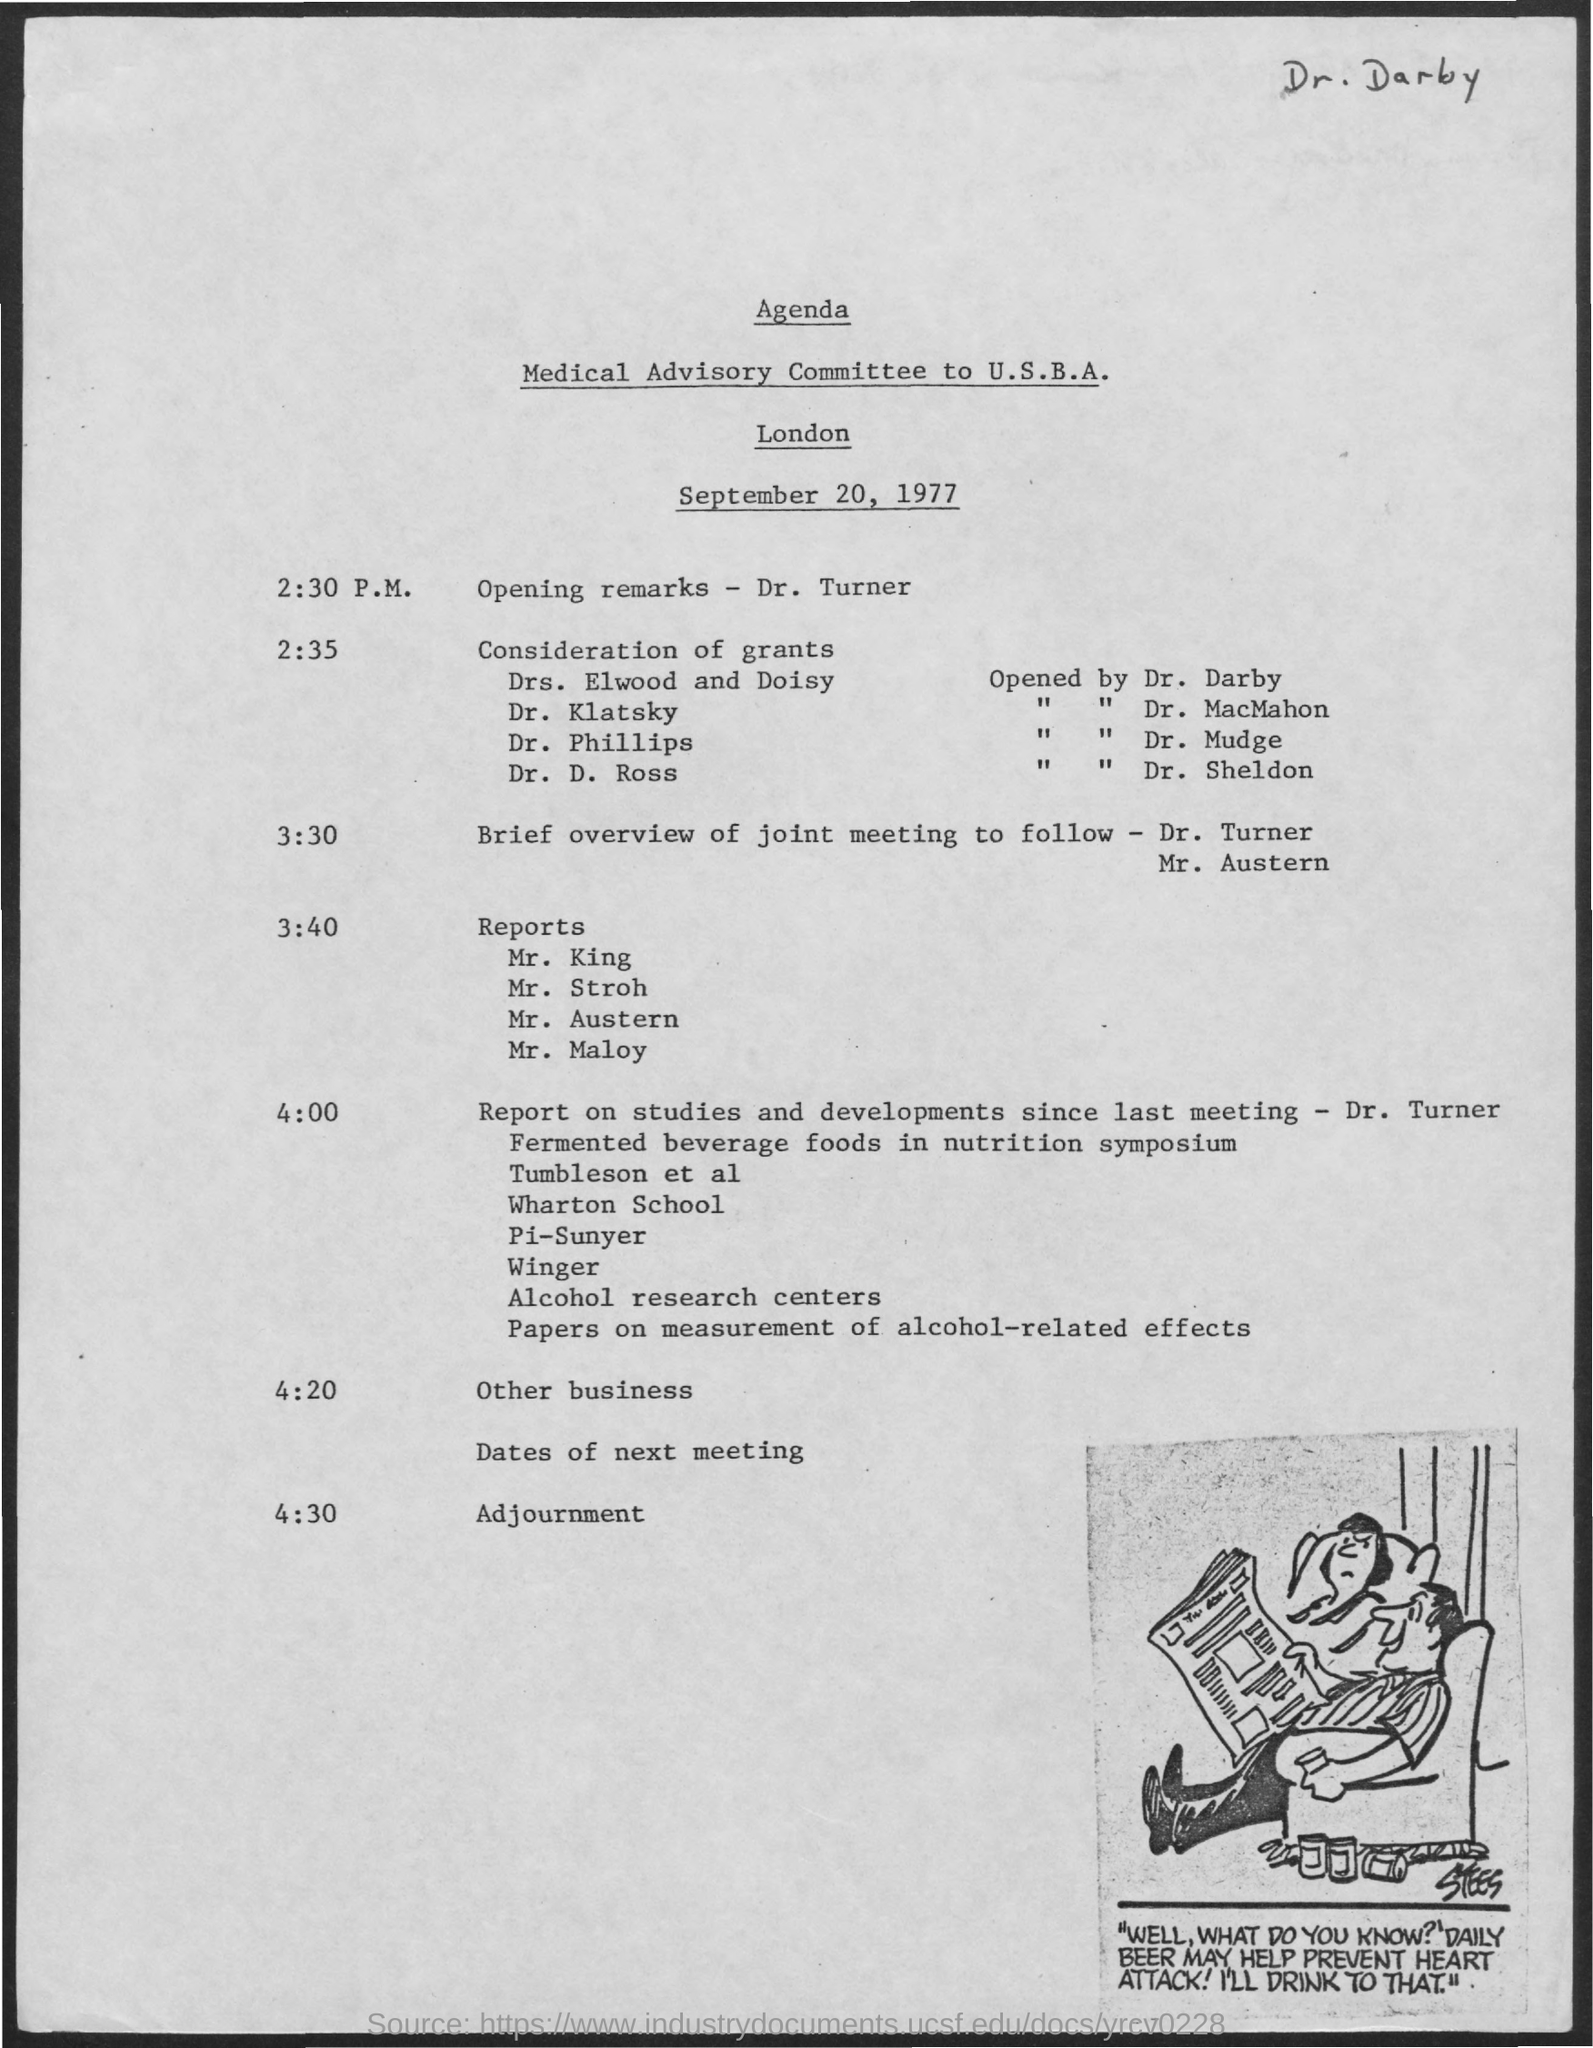Draw attention to some important aspects in this diagram. At 4:30 pm, the schedule was adjourned. At 2:35, the schedule will be considered with regard to grants. The date mentioned in the given page is September 20, 1977. At 3:40 pm, the schedule is currently being displayed. At 2:30 p.m., the schedule is unknown. 